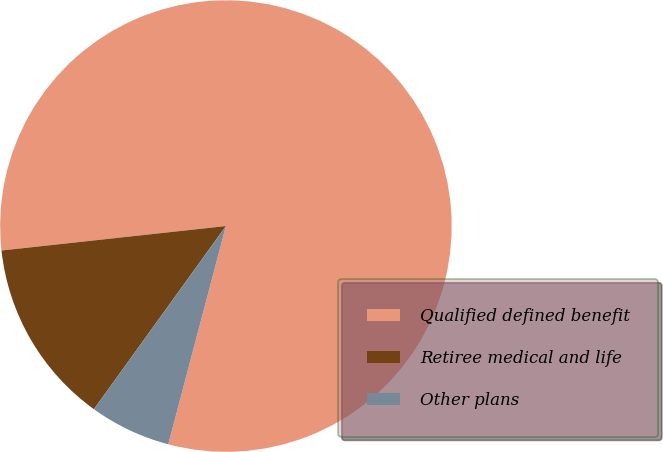<chart> <loc_0><loc_0><loc_500><loc_500><pie_chart><fcel>Qualified defined benefit<fcel>Retiree medical and life<fcel>Other plans<nl><fcel>80.83%<fcel>13.33%<fcel>5.83%<nl></chart> 